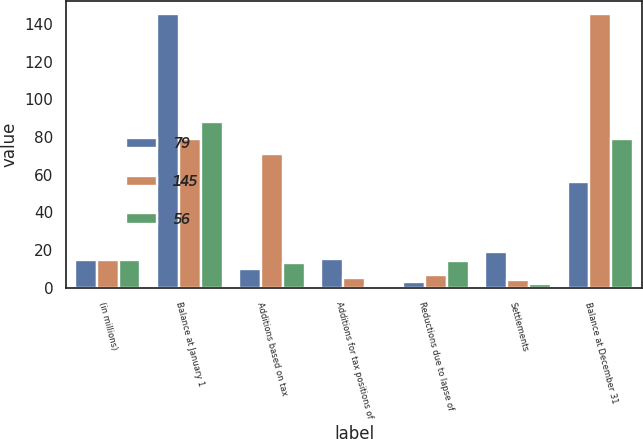Convert chart to OTSL. <chart><loc_0><loc_0><loc_500><loc_500><stacked_bar_chart><ecel><fcel>(in millions)<fcel>Balance at January 1<fcel>Additions based on tax<fcel>Additions for tax positions of<fcel>Reductions due to lapse of<fcel>Settlements<fcel>Balance at December 31<nl><fcel>79<fcel>14.5<fcel>145<fcel>10<fcel>15<fcel>3<fcel>19<fcel>56<nl><fcel>145<fcel>14.5<fcel>79<fcel>71<fcel>5<fcel>7<fcel>4<fcel>145<nl><fcel>56<fcel>14.5<fcel>88<fcel>13<fcel>1<fcel>14<fcel>2<fcel>79<nl></chart> 